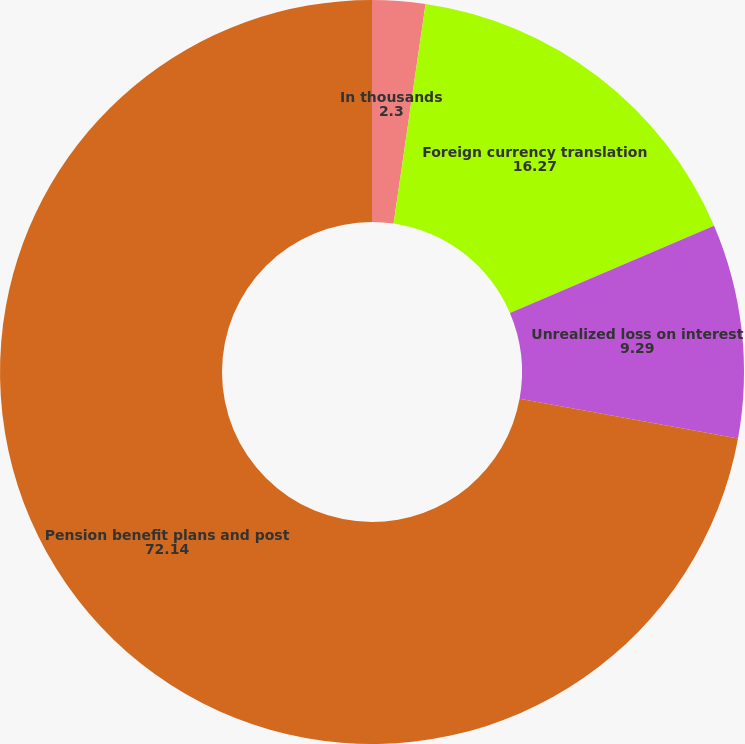<chart> <loc_0><loc_0><loc_500><loc_500><pie_chart><fcel>In thousands<fcel>Foreign currency translation<fcel>Unrealized loss on interest<fcel>Pension benefit plans and post<nl><fcel>2.3%<fcel>16.27%<fcel>9.29%<fcel>72.14%<nl></chart> 